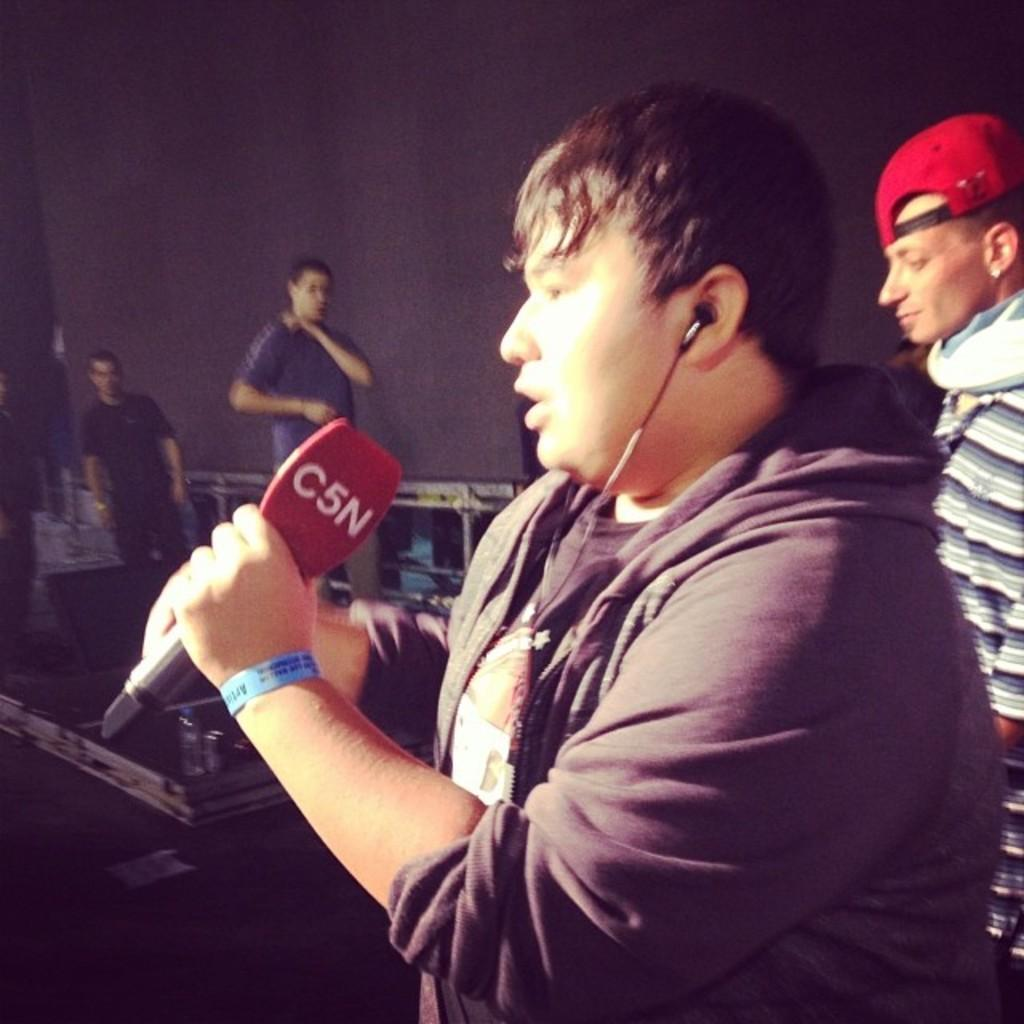What is the person in the image doing? The person is standing in the image and holding a microphone. What might the person be using in addition to the microphone? The person is wearing earphones. Can you describe the setting of the image? There are other people standing in the background of the image. What type of oatmeal is being sold in the shop in the image? There is no shop or oatmeal present in the image. 